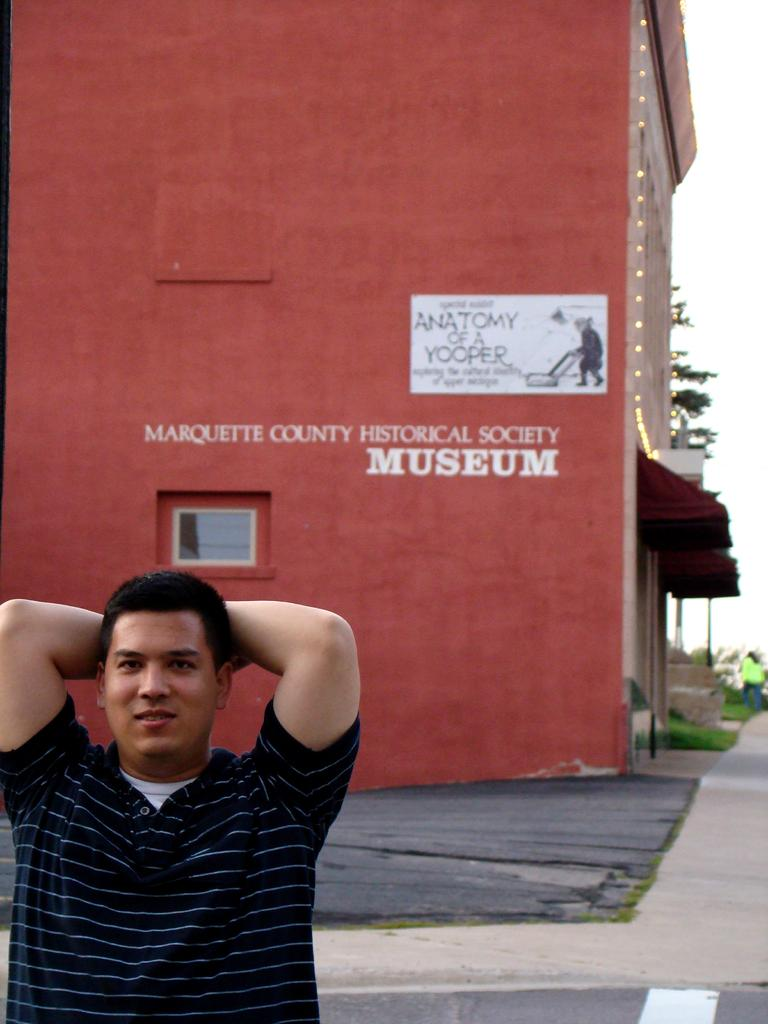Who or what is the main subject in the image? There is a person in the image. What can be seen in the distance behind the person? There is a building, trees, a road, and the sky visible in the background of the image. What role does the boy play in the image? There is no boy present in the image; it features a person. What type of actor is depicted in the image? There is no actor depicted in the image; it features a person. 